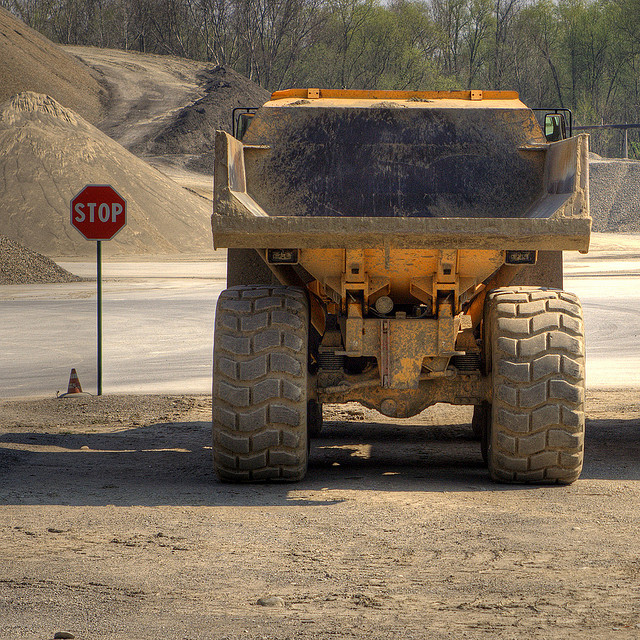Identify the text contained in this image. STOP 